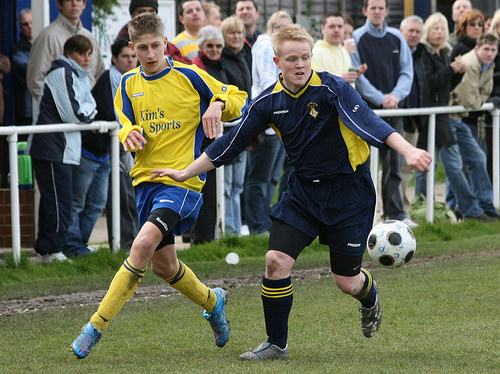<image>
Is there a ball on the boy? No. The ball is not positioned on the boy. They may be near each other, but the ball is not supported by or resting on top of the boy. Is the player one on the player two? No. The player one is not positioned on the player two. They may be near each other, but the player one is not supported by or resting on top of the player two. Where is the soccer player in relation to the fan? Is it to the left of the fan? No. The soccer player is not to the left of the fan. From this viewpoint, they have a different horizontal relationship. Where is the man in relation to the ball? Is it above the ball? Yes. The man is positioned above the ball in the vertical space, higher up in the scene. 